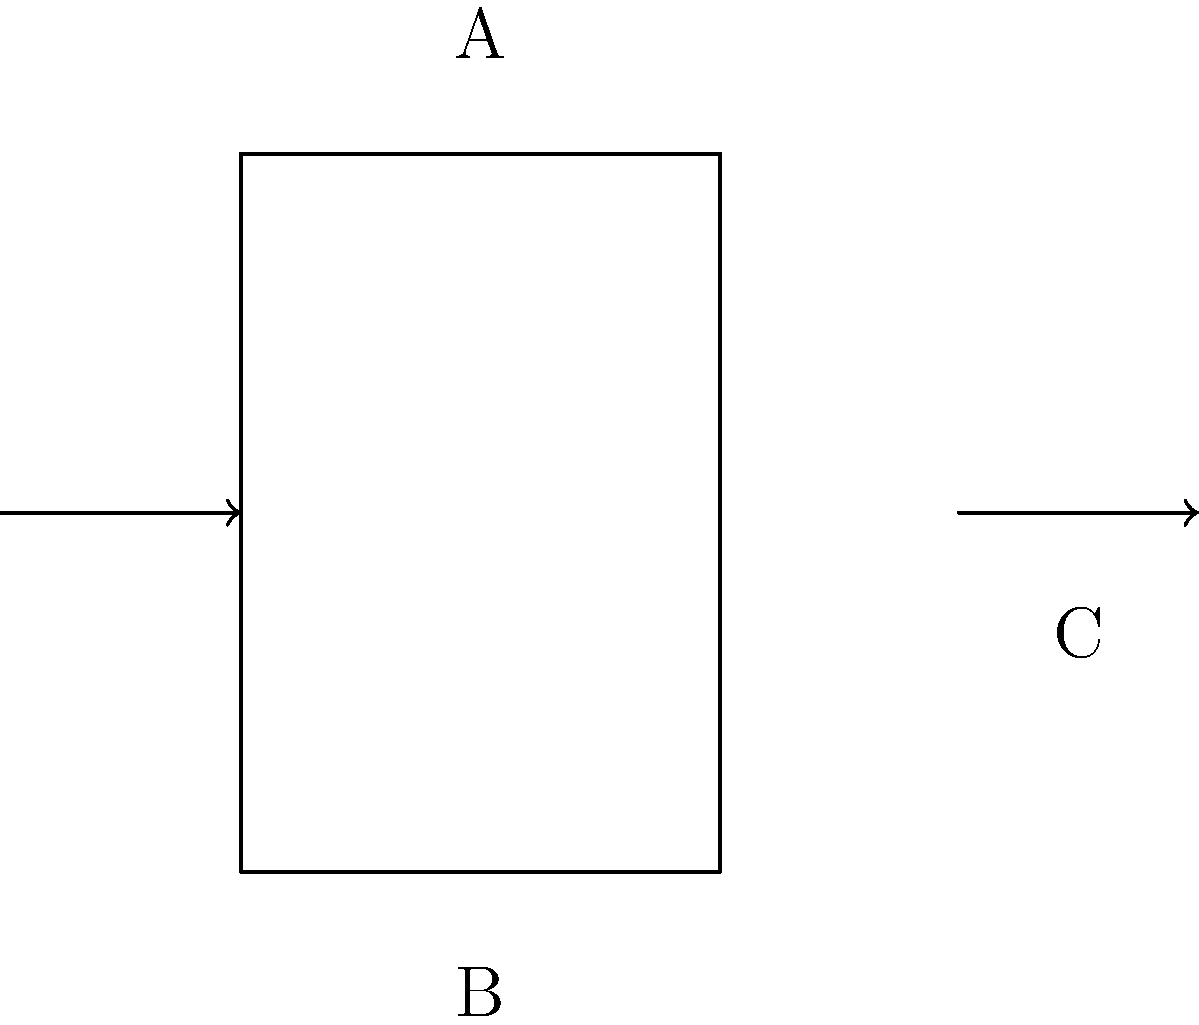As a camel spider enthusiast who often observes these arachnids in their desert habitats, you've become curious about how wind affects different structures. In the diagram above, three building shapes (A: cylinder, B: rectangle, C: triangle) are shown with wind direction indicated by arrows. Which shape is likely to experience the highest wind load coefficient, and why might this be relevant to understanding camel spider behavior in windy conditions? To answer this question, let's analyze each shape and its interaction with wind:

1. Cylinder (A):
   - Smooth, curved surface
   - Wind flows around it with less resistance
   - Experiences lower pressure differences

2. Rectangle (B):
   - Flat surface facing the wind
   - Creates a large area of high pressure on the windward side
   - Experiences significant pressure difference between windward and leeward sides

3. Triangle (C):
   - Sloped surface facing the wind
   - Deflects wind upward, reducing pressure on the windward side
   - Still experiences some pressure difference, but less than the rectangle

The rectangle (B) is likely to experience the highest wind load coefficient due to its large flat surface perpendicular to the wind direction, creating the greatest pressure difference.

Relevance to camel spider behavior:
1. Camel spiders often seek shelter in windy conditions
2. Understanding wind loads helps identify potential shelter spots in their habitat
3. Structures or objects similar to shape B might provide the best wind protection
4. Camel spiders may instinctively avoid open areas with high wind exposure
5. This knowledge can aid in designing suitable enclosures for camel spiders in captivity

The wind load coefficient is calculated using the formula:

$$C_f = \frac{F}{\frac{1}{2} \rho v^2 A}$$

Where:
$C_f$ = Wind load coefficient
$F$ = Wind force
$\rho$ = Air density
$v$ = Wind velocity
$A$ = Projected area normal to the wind

The rectangle (B) maximizes the projected area $A$, leading to the highest wind load coefficient.
Answer: Rectangle (B); helps understand camel spider shelter-seeking behavior in windy conditions. 